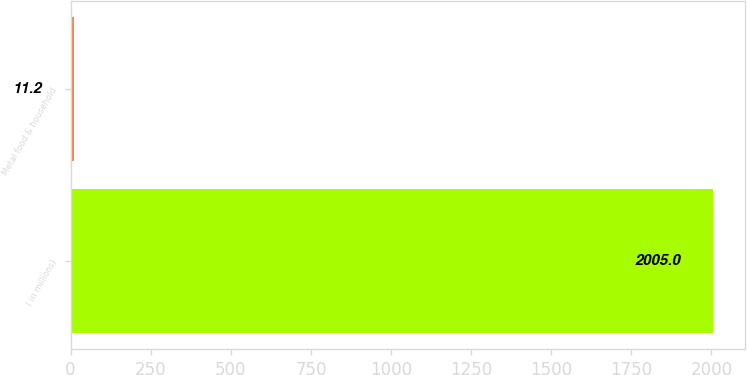<chart> <loc_0><loc_0><loc_500><loc_500><bar_chart><fcel>( in millions)<fcel>Metal food & household<nl><fcel>2005<fcel>11.2<nl></chart> 